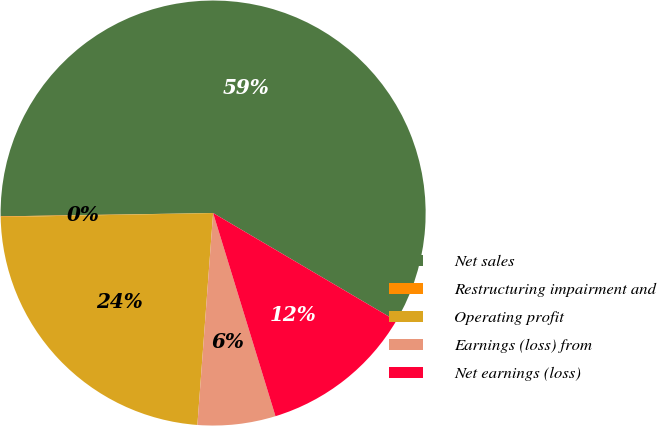<chart> <loc_0><loc_0><loc_500><loc_500><pie_chart><fcel>Net sales<fcel>Restructuring impairment and<fcel>Operating profit<fcel>Earnings (loss) from<fcel>Net earnings (loss)<nl><fcel>58.72%<fcel>0.05%<fcel>23.52%<fcel>5.92%<fcel>11.79%<nl></chart> 